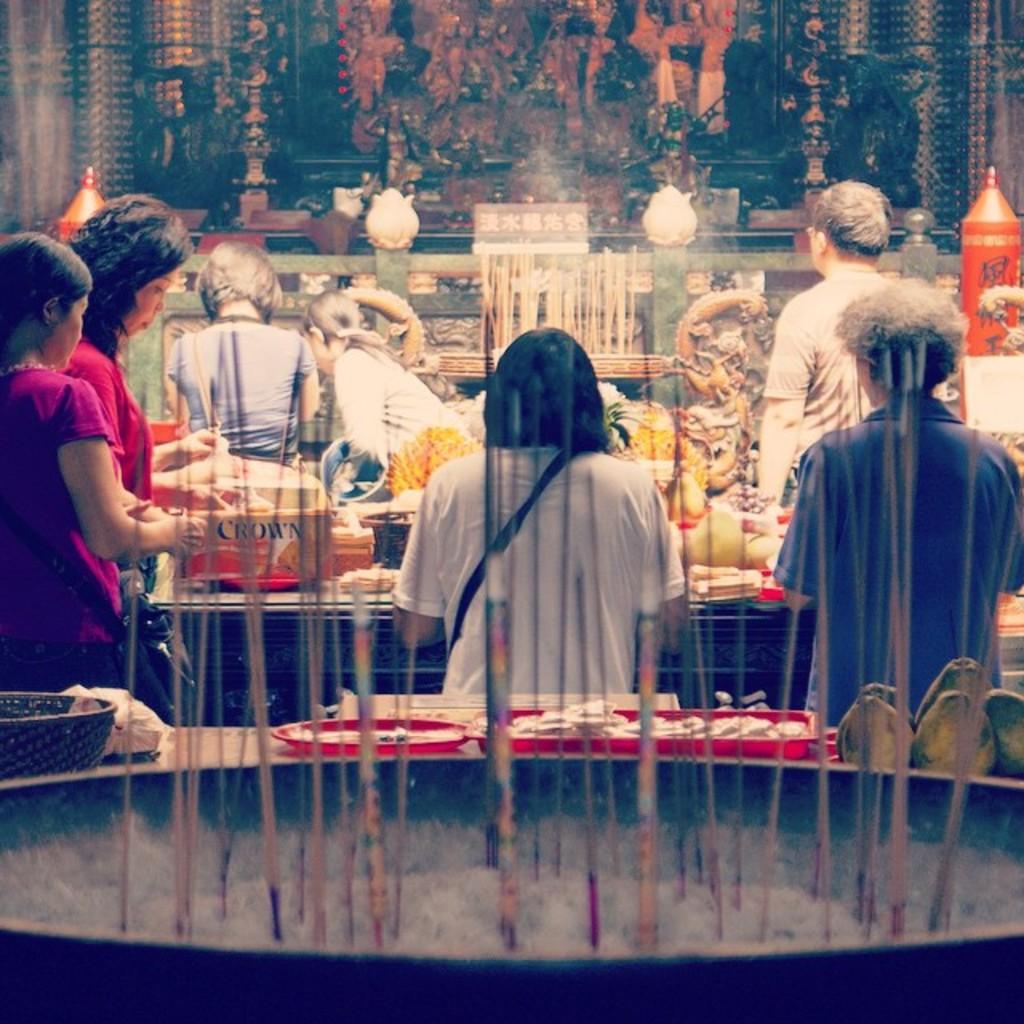How would you summarize this image in a sentence or two? In the picture there are few people and around them there are many food items and in the front there is some object and in the background there is some poster to the wall. 